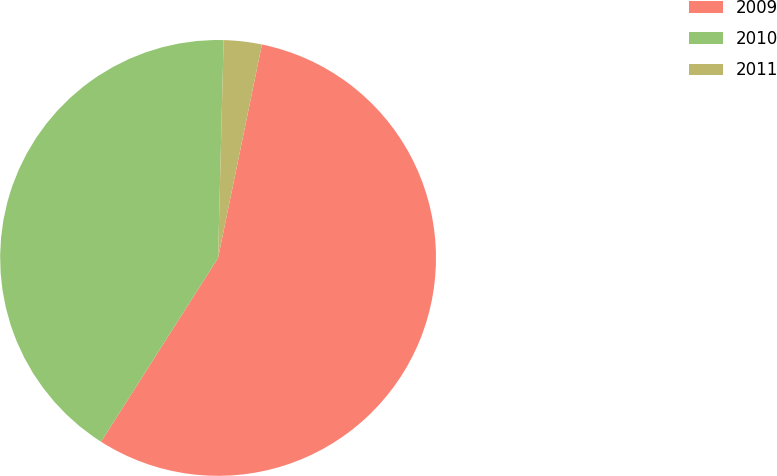<chart> <loc_0><loc_0><loc_500><loc_500><pie_chart><fcel>2009<fcel>2010<fcel>2011<nl><fcel>55.8%<fcel>41.38%<fcel>2.82%<nl></chart> 